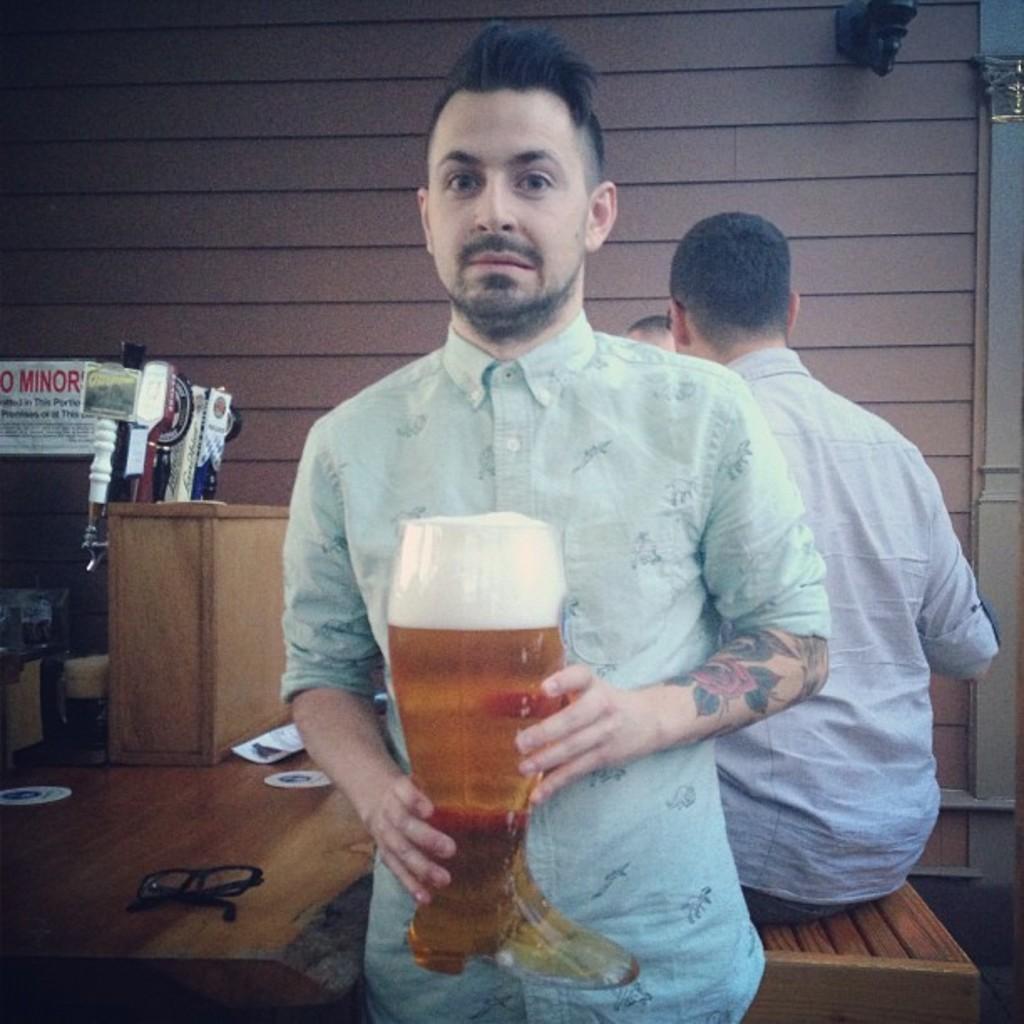How would you summarize this image in a sentence or two? In this image there are three persons. The man is holding a glass. On the table there are glasses and some objects. 